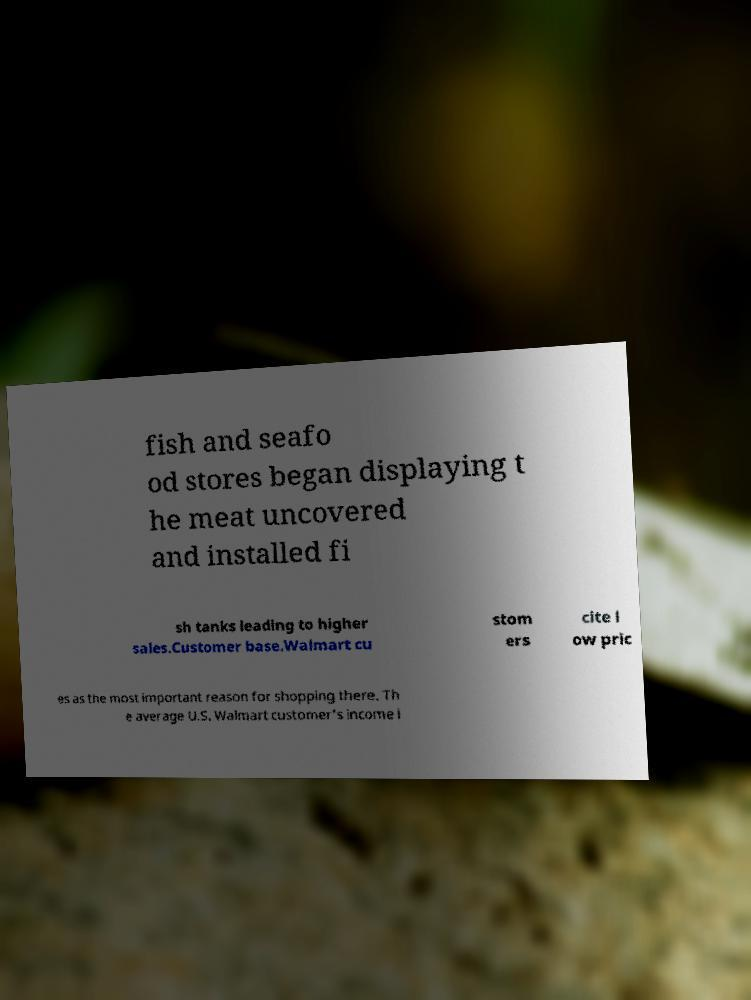Can you accurately transcribe the text from the provided image for me? fish and seafo od stores began displaying t he meat uncovered and installed fi sh tanks leading to higher sales.Customer base.Walmart cu stom ers cite l ow pric es as the most important reason for shopping there. Th e average U.S. Walmart customer's income i 